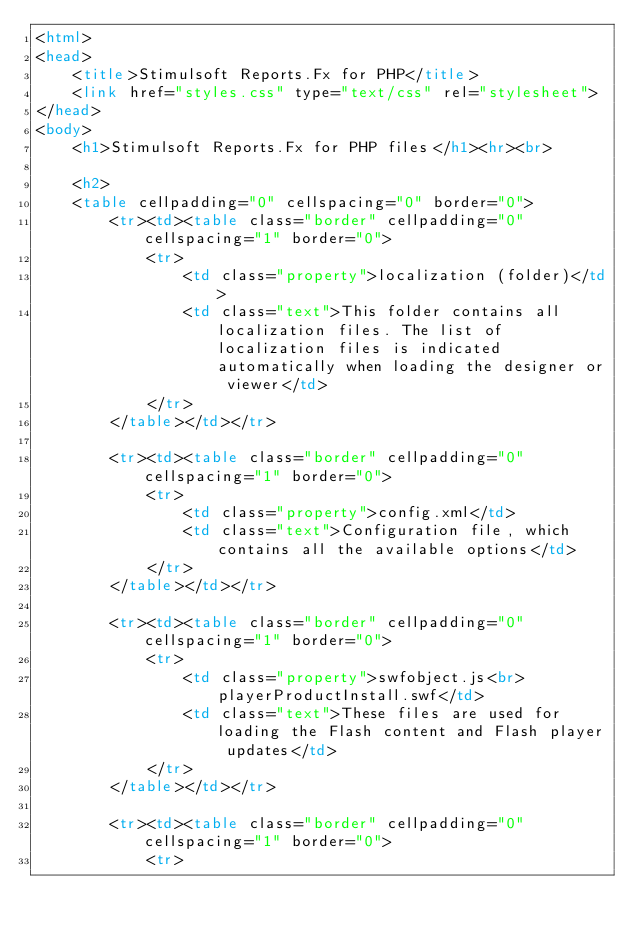<code> <loc_0><loc_0><loc_500><loc_500><_HTML_><html>
<head>
	<title>Stimulsoft Reports.Fx for PHP</title>
	<link href="styles.css" type="text/css" rel="stylesheet">
</head>
<body>
	<h1>Stimulsoft Reports.Fx for PHP files</h1><hr><br>
	
	<h2>
	<table cellpadding="0" cellspacing="0" border="0">
		<tr><td><table class="border" cellpadding="0" cellspacing="1" border="0">
			<tr>
				<td class="property">localization (folder)</td>
				<td class="text">This folder contains all localization files. The list of localization files is indicated automatically when loading the designer or viewer</td>
			</tr>
		</table></td></tr>
		
		<tr><td><table class="border" cellpadding="0" cellspacing="1" border="0">
			<tr>
				<td class="property">config.xml</td>
				<td class="text">Configuration file, which contains all the available options</td>
			</tr>
		</table></td></tr>
		
		<tr><td><table class="border" cellpadding="0" cellspacing="1" border="0">
			<tr>
				<td class="property">swfobject.js<br>playerProductInstall.swf</td>
				<td class="text">These files are used for loading the Flash content and Flash player updates</td>
			</tr>
		</table></td></tr>
		
		<tr><td><table class="border" cellpadding="0" cellspacing="1" border="0">
			<tr></code> 